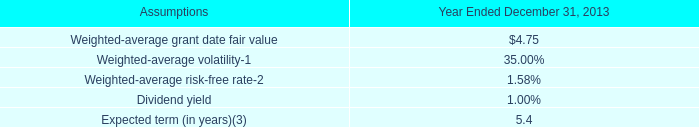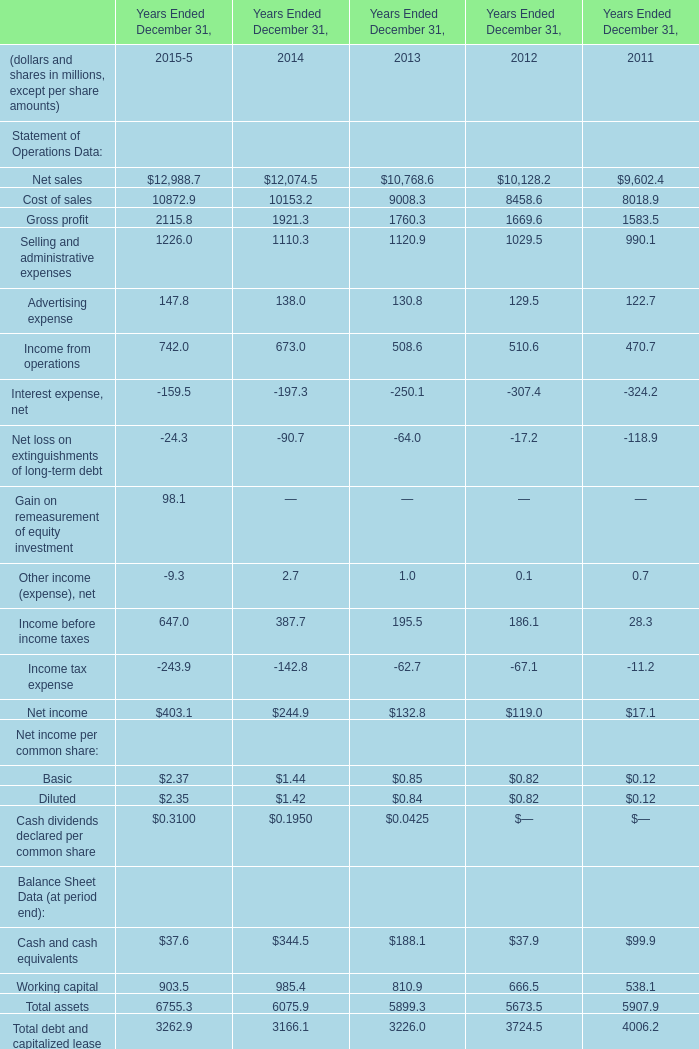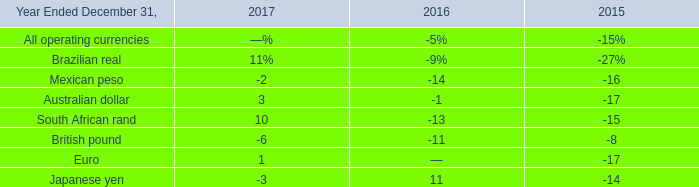What will total assets reach in 2016 if it continues to grow at its current rate? (in million) 
Computations: ((((6755.3 - 6075.9) / 6075.9) + 1) * 6755.3)
Answer: 7510.66971. 